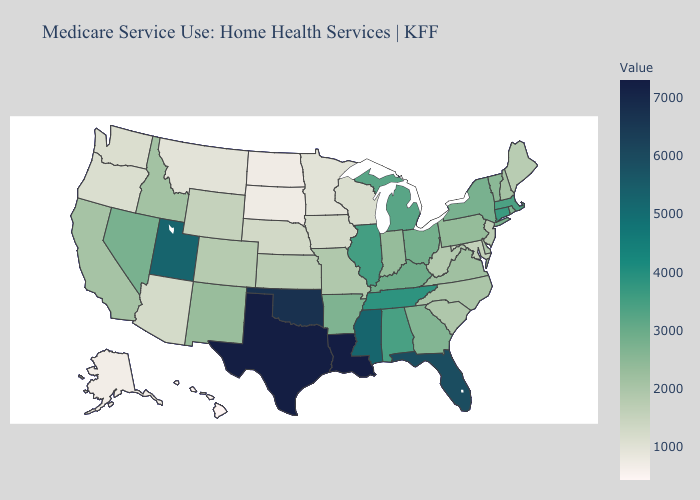Does Alaska have the highest value in the USA?
Quick response, please. No. Does Rhode Island have the highest value in the Northeast?
Concise answer only. No. Does Vermont have a higher value than Kansas?
Keep it brief. Yes. Which states have the lowest value in the USA?
Write a very short answer. Hawaii. Does Ohio have a lower value than Alaska?
Write a very short answer. No. Does North Dakota have a lower value than Massachusetts?
Keep it brief. Yes. Does the map have missing data?
Keep it brief. No. 